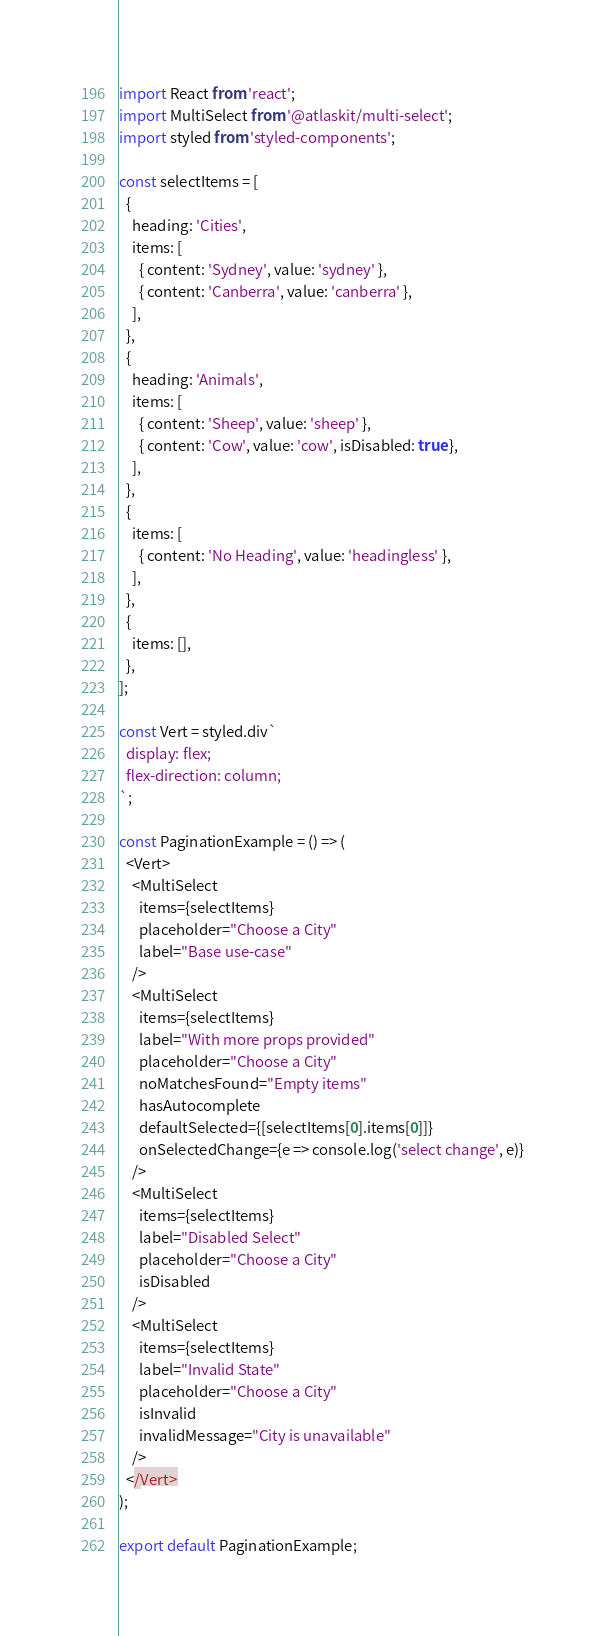<code> <loc_0><loc_0><loc_500><loc_500><_JavaScript_>import React from 'react';
import MultiSelect from '@atlaskit/multi-select';
import styled from 'styled-components';

const selectItems = [
  {
    heading: 'Cities',
    items: [
      { content: 'Sydney', value: 'sydney' },
      { content: 'Canberra', value: 'canberra' },
    ],
  },
  {
    heading: 'Animals',
    items: [
      { content: 'Sheep', value: 'sheep' },
      { content: 'Cow', value: 'cow', isDisabled: true },
    ],
  },
  {
    items: [
      { content: 'No Heading', value: 'headingless' },
    ],
  },
  {
    items: [],
  },
];

const Vert = styled.div`
  display: flex;
  flex-direction: column;
`;

const PaginationExample = () => (
  <Vert>
    <MultiSelect
      items={selectItems}
      placeholder="Choose a City"
      label="Base use-case"
    />
    <MultiSelect
      items={selectItems}
      label="With more props provided"
      placeholder="Choose a City"
      noMatchesFound="Empty items"
      hasAutocomplete
      defaultSelected={[selectItems[0].items[0]]}
      onSelectedChange={e => console.log('select change', e)}
    />
    <MultiSelect
      items={selectItems}
      label="Disabled Select"
      placeholder="Choose a City"
      isDisabled
    />
    <MultiSelect
      items={selectItems}
      label="Invalid State"
      placeholder="Choose a City"
      isInvalid
      invalidMessage="City is unavailable"
    />
  </Vert>
);

export default PaginationExample;
</code> 